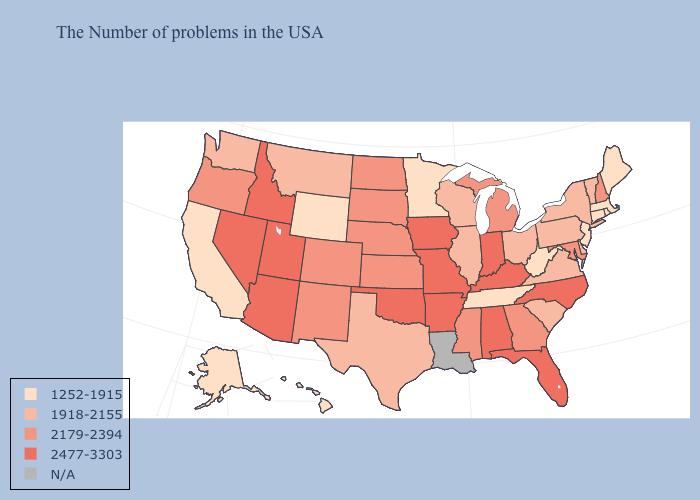Does the first symbol in the legend represent the smallest category?
Short answer required. Yes. What is the value of Oklahoma?
Keep it brief. 2477-3303. Among the states that border Tennessee , does Virginia have the lowest value?
Keep it brief. Yes. Does Alaska have the lowest value in the USA?
Give a very brief answer. Yes. What is the value of Connecticut?
Short answer required. 1252-1915. What is the value of Maine?
Concise answer only. 1252-1915. Name the states that have a value in the range N/A?
Give a very brief answer. Louisiana. Does Illinois have the lowest value in the MidWest?
Quick response, please. No. Among the states that border Connecticut , does New York have the highest value?
Short answer required. Yes. Is the legend a continuous bar?
Quick response, please. No. What is the value of Nevada?
Be succinct. 2477-3303. 